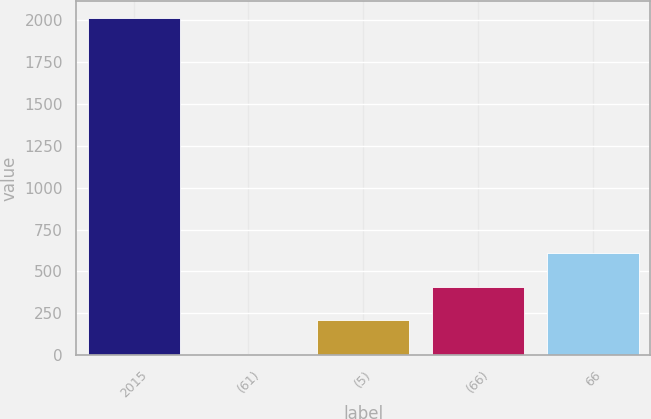<chart> <loc_0><loc_0><loc_500><loc_500><bar_chart><fcel>2015<fcel>(61)<fcel>(5)<fcel>(66)<fcel>66<nl><fcel>2015<fcel>6<fcel>206.9<fcel>407.8<fcel>608.7<nl></chart> 